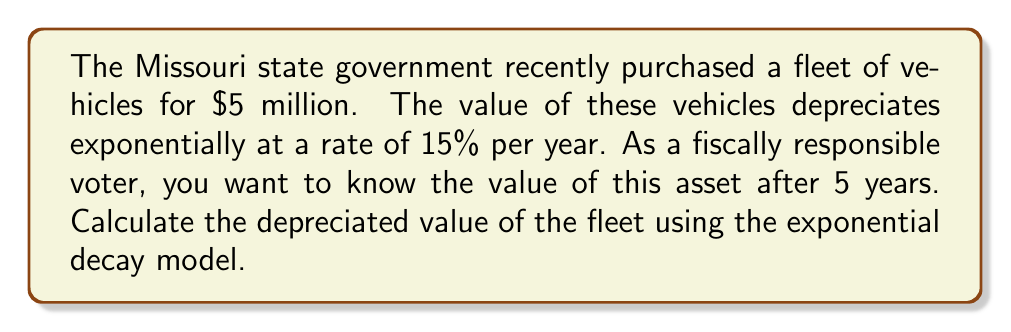Provide a solution to this math problem. To solve this problem, we'll use the exponential decay formula:

$$A(t) = A_0 e^{-rt}$$

Where:
$A(t)$ is the value after time $t$
$A_0$ is the initial value
$r$ is the decay rate
$t$ is the time in years

Given:
$A_0 = \$5,000,000$ (initial value)
$r = 0.15$ (15% annual depreciation rate)
$t = 5$ years

Let's substitute these values into the formula:

$$A(5) = 5,000,000 \cdot e^{-0.15 \cdot 5}$$

Now, let's calculate:

$$A(5) = 5,000,000 \cdot e^{-0.75}$$
$$A(5) = 5,000,000 \cdot 0.4723$$
$$A(5) = 2,361,500$$

Therefore, after 5 years, the value of the fleet will be approximately $2,361,500.
Answer: $2,361,500 